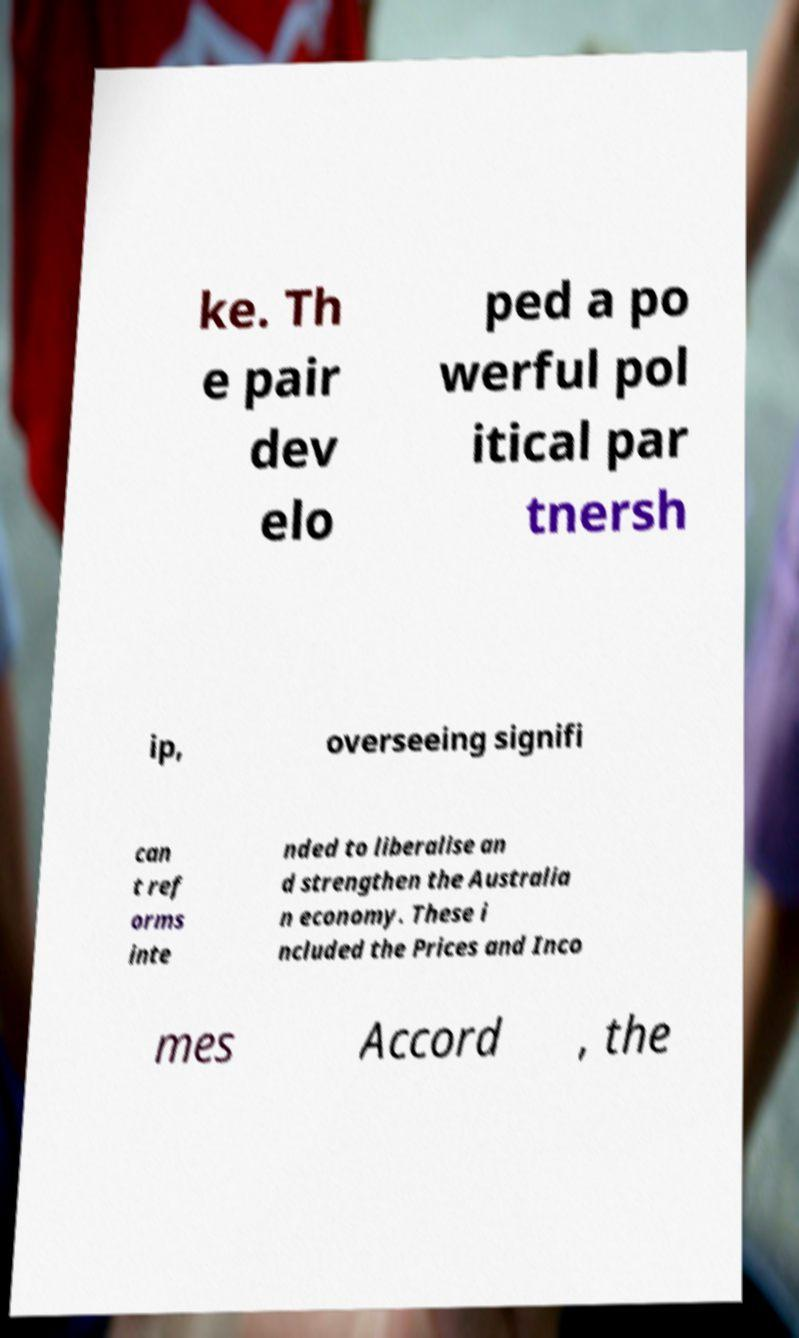Can you read and provide the text displayed in the image?This photo seems to have some interesting text. Can you extract and type it out for me? ke. Th e pair dev elo ped a po werful pol itical par tnersh ip, overseeing signifi can t ref orms inte nded to liberalise an d strengthen the Australia n economy. These i ncluded the Prices and Inco mes Accord , the 